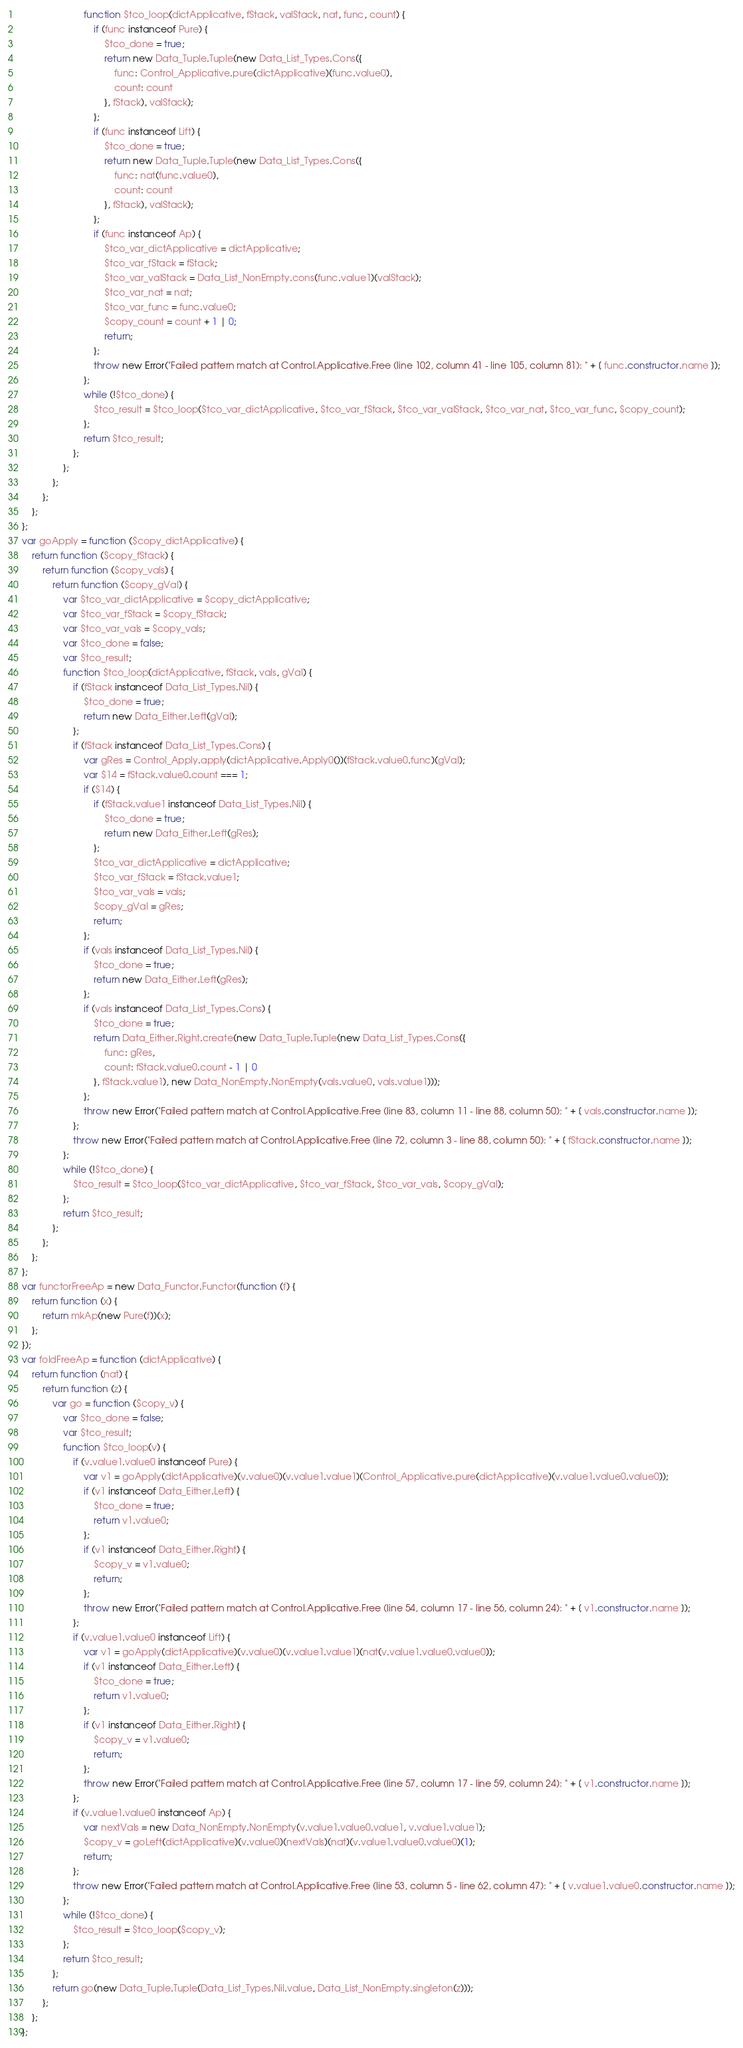<code> <loc_0><loc_0><loc_500><loc_500><_JavaScript_>                          function $tco_loop(dictApplicative, fStack, valStack, nat, func, count) {
                              if (func instanceof Pure) {
                                  $tco_done = true;
                                  return new Data_Tuple.Tuple(new Data_List_Types.Cons({
                                      func: Control_Applicative.pure(dictApplicative)(func.value0),
                                      count: count
                                  }, fStack), valStack);
                              };
                              if (func instanceof Lift) {
                                  $tco_done = true;
                                  return new Data_Tuple.Tuple(new Data_List_Types.Cons({
                                      func: nat(func.value0),
                                      count: count
                                  }, fStack), valStack);
                              };
                              if (func instanceof Ap) {
                                  $tco_var_dictApplicative = dictApplicative;
                                  $tco_var_fStack = fStack;
                                  $tco_var_valStack = Data_List_NonEmpty.cons(func.value1)(valStack);
                                  $tco_var_nat = nat;
                                  $tco_var_func = func.value0;
                                  $copy_count = count + 1 | 0;
                                  return;
                              };
                              throw new Error("Failed pattern match at Control.Applicative.Free (line 102, column 41 - line 105, column 81): " + [ func.constructor.name ]);
                          };
                          while (!$tco_done) {
                              $tco_result = $tco_loop($tco_var_dictApplicative, $tco_var_fStack, $tco_var_valStack, $tco_var_nat, $tco_var_func, $copy_count);
                          };
                          return $tco_result;
                      };
                  };
              };
          };
      };
  };
  var goApply = function ($copy_dictApplicative) {
      return function ($copy_fStack) {
          return function ($copy_vals) {
              return function ($copy_gVal) {
                  var $tco_var_dictApplicative = $copy_dictApplicative;
                  var $tco_var_fStack = $copy_fStack;
                  var $tco_var_vals = $copy_vals;
                  var $tco_done = false;
                  var $tco_result;
                  function $tco_loop(dictApplicative, fStack, vals, gVal) {
                      if (fStack instanceof Data_List_Types.Nil) {
                          $tco_done = true;
                          return new Data_Either.Left(gVal);
                      };
                      if (fStack instanceof Data_List_Types.Cons) {
                          var gRes = Control_Apply.apply(dictApplicative.Apply0())(fStack.value0.func)(gVal);
                          var $14 = fStack.value0.count === 1;
                          if ($14) {
                              if (fStack.value1 instanceof Data_List_Types.Nil) {
                                  $tco_done = true;
                                  return new Data_Either.Left(gRes);
                              };
                              $tco_var_dictApplicative = dictApplicative;
                              $tco_var_fStack = fStack.value1;
                              $tco_var_vals = vals;
                              $copy_gVal = gRes;
                              return;
                          };
                          if (vals instanceof Data_List_Types.Nil) {
                              $tco_done = true;
                              return new Data_Either.Left(gRes);
                          };
                          if (vals instanceof Data_List_Types.Cons) {
                              $tco_done = true;
                              return Data_Either.Right.create(new Data_Tuple.Tuple(new Data_List_Types.Cons({
                                  func: gRes,
                                  count: fStack.value0.count - 1 | 0
                              }, fStack.value1), new Data_NonEmpty.NonEmpty(vals.value0, vals.value1)));
                          };
                          throw new Error("Failed pattern match at Control.Applicative.Free (line 83, column 11 - line 88, column 50): " + [ vals.constructor.name ]);
                      };
                      throw new Error("Failed pattern match at Control.Applicative.Free (line 72, column 3 - line 88, column 50): " + [ fStack.constructor.name ]);
                  };
                  while (!$tco_done) {
                      $tco_result = $tco_loop($tco_var_dictApplicative, $tco_var_fStack, $tco_var_vals, $copy_gVal);
                  };
                  return $tco_result;
              };
          };
      };
  };
  var functorFreeAp = new Data_Functor.Functor(function (f) {
      return function (x) {
          return mkAp(new Pure(f))(x);
      };
  });
  var foldFreeAp = function (dictApplicative) {
      return function (nat) {
          return function (z) {
              var go = function ($copy_v) {
                  var $tco_done = false;
                  var $tco_result;
                  function $tco_loop(v) {
                      if (v.value1.value0 instanceof Pure) {
                          var v1 = goApply(dictApplicative)(v.value0)(v.value1.value1)(Control_Applicative.pure(dictApplicative)(v.value1.value0.value0));
                          if (v1 instanceof Data_Either.Left) {
                              $tco_done = true;
                              return v1.value0;
                          };
                          if (v1 instanceof Data_Either.Right) {
                              $copy_v = v1.value0;
                              return;
                          };
                          throw new Error("Failed pattern match at Control.Applicative.Free (line 54, column 17 - line 56, column 24): " + [ v1.constructor.name ]);
                      };
                      if (v.value1.value0 instanceof Lift) {
                          var v1 = goApply(dictApplicative)(v.value0)(v.value1.value1)(nat(v.value1.value0.value0));
                          if (v1 instanceof Data_Either.Left) {
                              $tco_done = true;
                              return v1.value0;
                          };
                          if (v1 instanceof Data_Either.Right) {
                              $copy_v = v1.value0;
                              return;
                          };
                          throw new Error("Failed pattern match at Control.Applicative.Free (line 57, column 17 - line 59, column 24): " + [ v1.constructor.name ]);
                      };
                      if (v.value1.value0 instanceof Ap) {
                          var nextVals = new Data_NonEmpty.NonEmpty(v.value1.value0.value1, v.value1.value1);
                          $copy_v = goLeft(dictApplicative)(v.value0)(nextVals)(nat)(v.value1.value0.value0)(1);
                          return;
                      };
                      throw new Error("Failed pattern match at Control.Applicative.Free (line 53, column 5 - line 62, column 47): " + [ v.value1.value0.constructor.name ]);
                  };
                  while (!$tco_done) {
                      $tco_result = $tco_loop($copy_v);
                  };
                  return $tco_result;
              };
              return go(new Data_Tuple.Tuple(Data_List_Types.Nil.value, Data_List_NonEmpty.singleton(z)));
          };
      };
  };</code> 